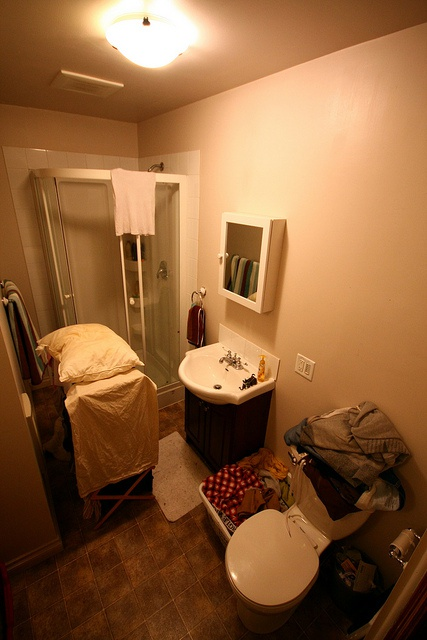Describe the objects in this image and their specific colors. I can see toilet in maroon, red, black, and tan tones, sink in maroon, tan, and brown tones, handbag in maroon, black, and brown tones, and bottle in maroon, red, orange, and tan tones in this image. 